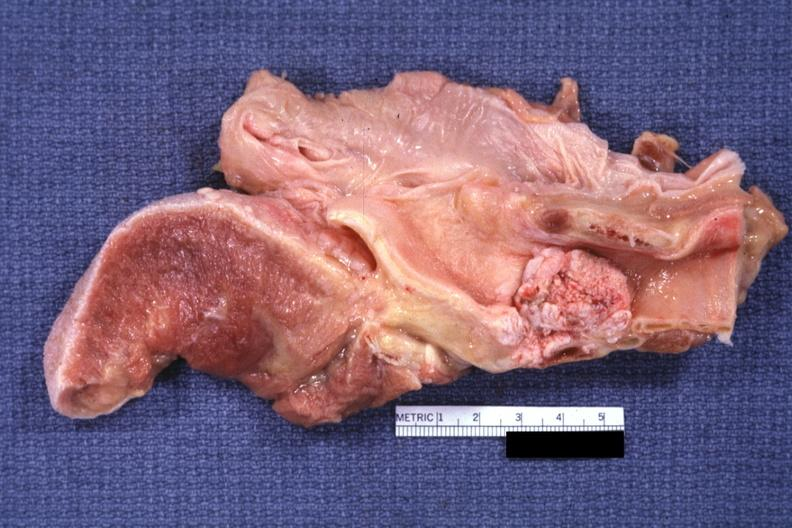s carcinoma present?
Answer the question using a single word or phrase. Yes 